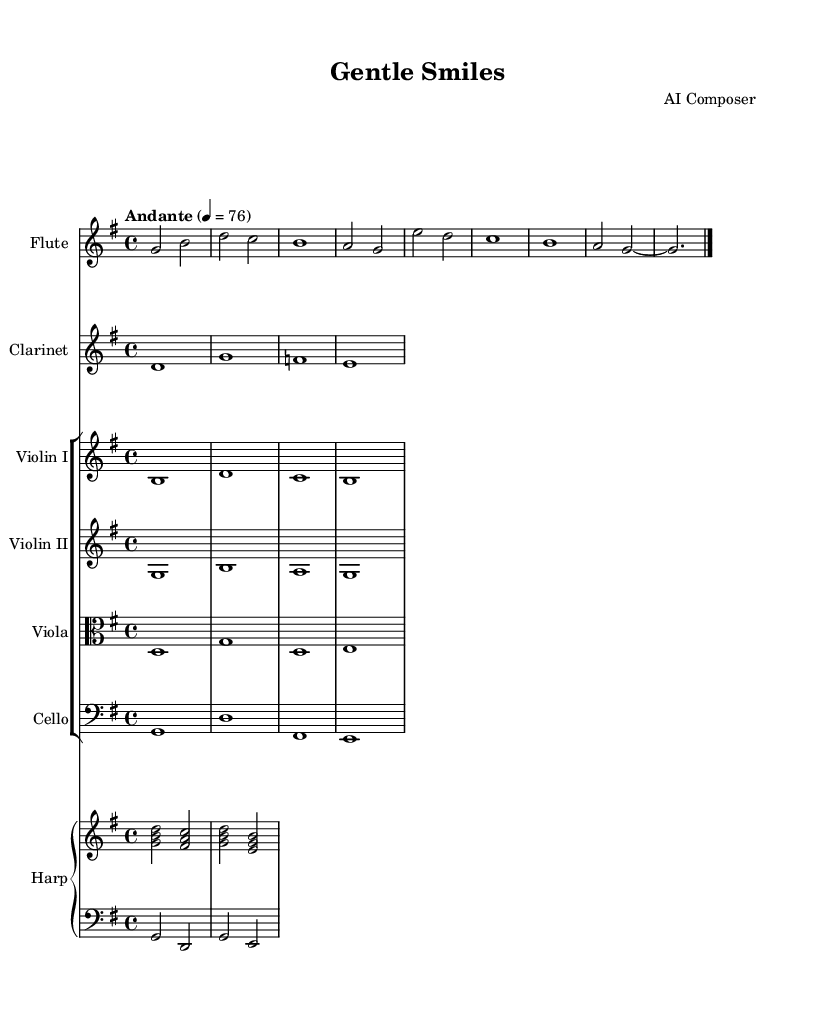What is the key signature of this music? The key signature is indicated at the beginning of the staff. In this case, it shows one sharp, which corresponds to G major.
Answer: G major What is the time signature of this music? The time signature appears after the key signature. Here, it is marked as 4/4, which means there are four beats in each measure and the quarter note gets one beat.
Answer: 4/4 What is the tempo marking for this piece? The tempo marking is usually found at the beginning of the sheet music. This piece is marked "Andante," which indicates a moderate pace, at a speed of 76 beats per minute.
Answer: Andante How many instruments are indicated in the score? By examining the score, we can see there are six different staves representing various instruments including flute, clarinet, two violins, viola, cello, and harp.
Answer: Six Which instrument has the highest pitch? To determine the highest pitch, we look at the notes played by each instrument. The flute typically plays higher than the others, and in this score, it is the highest as it starts with G, which is higher than the initial notes of the other instruments.
Answer: Flute How many measures are in the piece? A measure is defined by a vertical bar line in the score. In this excerpt, there is one measure that contains all the notes provided, indicated by the bar line at the end.
Answer: One What is the dynamic marking for this piece? In this music, there is no explicit dynamic marking shown in the provided excerpt of the score, as it would typically be indicated by symbols like "p" for piano or "f" for forte. In this case, we can assume a gentle dynamic due to the overall soothing nature of the piece.
Answer: None indicated 